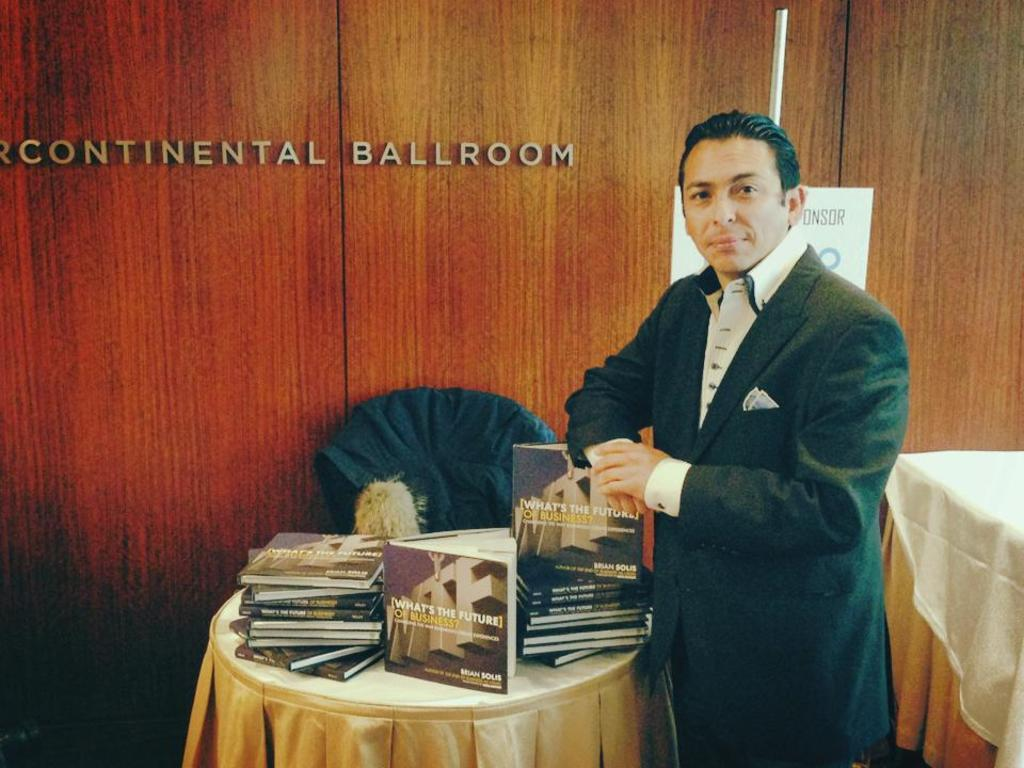Provide a one-sentence caption for the provided image. A man in a suit standing next to a table full of books titled "What's The Future of Business?". 